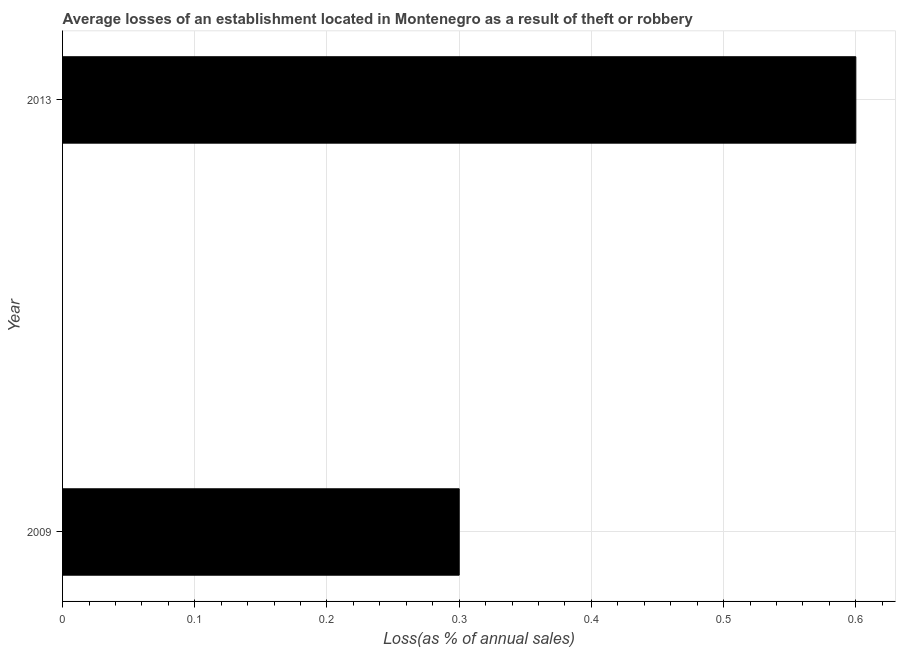Does the graph contain any zero values?
Offer a very short reply. No. What is the title of the graph?
Provide a succinct answer. Average losses of an establishment located in Montenegro as a result of theft or robbery. What is the label or title of the X-axis?
Keep it short and to the point. Loss(as % of annual sales). Across all years, what is the maximum losses due to theft?
Ensure brevity in your answer.  0.6. In which year was the losses due to theft minimum?
Offer a very short reply. 2009. What is the sum of the losses due to theft?
Offer a terse response. 0.9. What is the average losses due to theft per year?
Ensure brevity in your answer.  0.45. What is the median losses due to theft?
Offer a very short reply. 0.45. What is the ratio of the losses due to theft in 2009 to that in 2013?
Provide a succinct answer. 0.5. Is the losses due to theft in 2009 less than that in 2013?
Offer a terse response. Yes. In how many years, is the losses due to theft greater than the average losses due to theft taken over all years?
Provide a succinct answer. 1. How many years are there in the graph?
Ensure brevity in your answer.  2. What is the difference between two consecutive major ticks on the X-axis?
Ensure brevity in your answer.  0.1. What is the Loss(as % of annual sales) of 2009?
Provide a short and direct response. 0.3. 